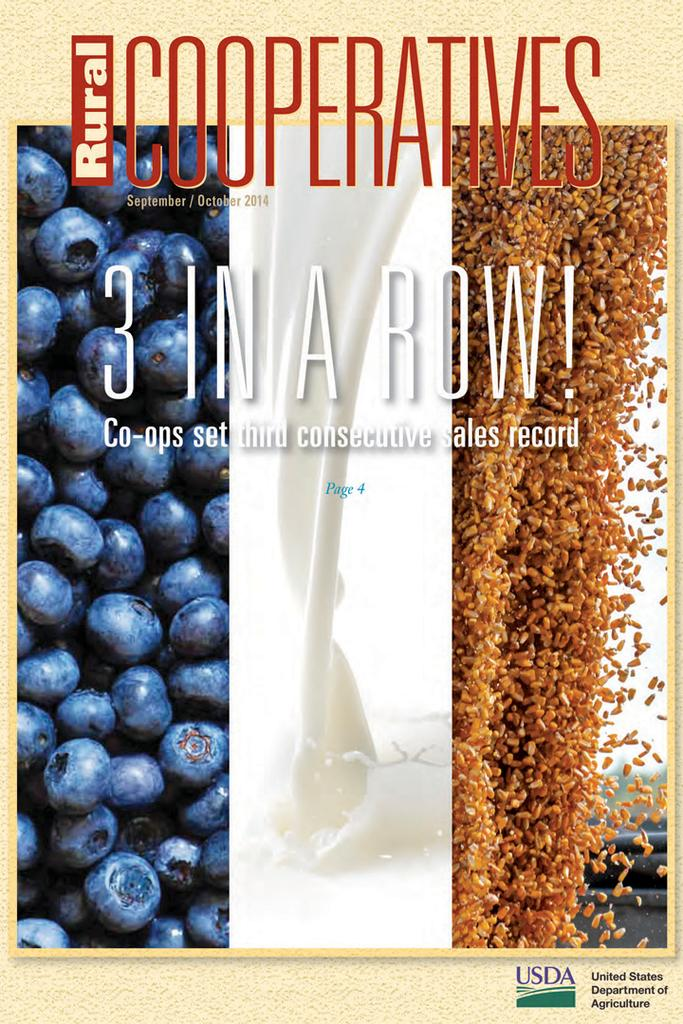<image>
Provide a brief description of the given image. the september/october cover of the cooperatives magazine with blueberries, milk and grains 